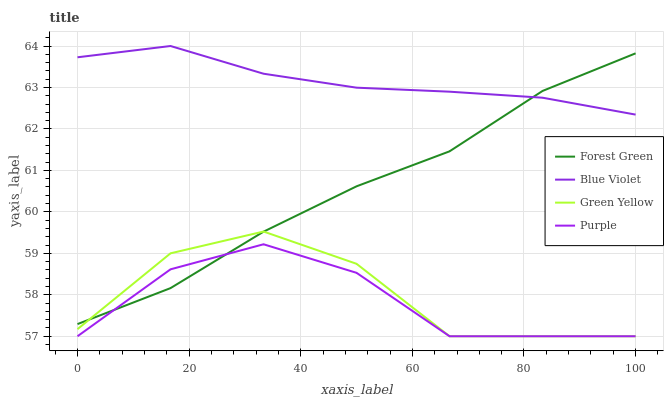Does Purple have the minimum area under the curve?
Answer yes or no. Yes. Does Blue Violet have the maximum area under the curve?
Answer yes or no. Yes. Does Forest Green have the minimum area under the curve?
Answer yes or no. No. Does Forest Green have the maximum area under the curve?
Answer yes or no. No. Is Blue Violet the smoothest?
Answer yes or no. Yes. Is Green Yellow the roughest?
Answer yes or no. Yes. Is Forest Green the smoothest?
Answer yes or no. No. Is Forest Green the roughest?
Answer yes or no. No. Does Purple have the lowest value?
Answer yes or no. Yes. Does Forest Green have the lowest value?
Answer yes or no. No. Does Blue Violet have the highest value?
Answer yes or no. Yes. Does Forest Green have the highest value?
Answer yes or no. No. Is Green Yellow less than Blue Violet?
Answer yes or no. Yes. Is Blue Violet greater than Purple?
Answer yes or no. Yes. Does Green Yellow intersect Purple?
Answer yes or no. Yes. Is Green Yellow less than Purple?
Answer yes or no. No. Is Green Yellow greater than Purple?
Answer yes or no. No. Does Green Yellow intersect Blue Violet?
Answer yes or no. No. 